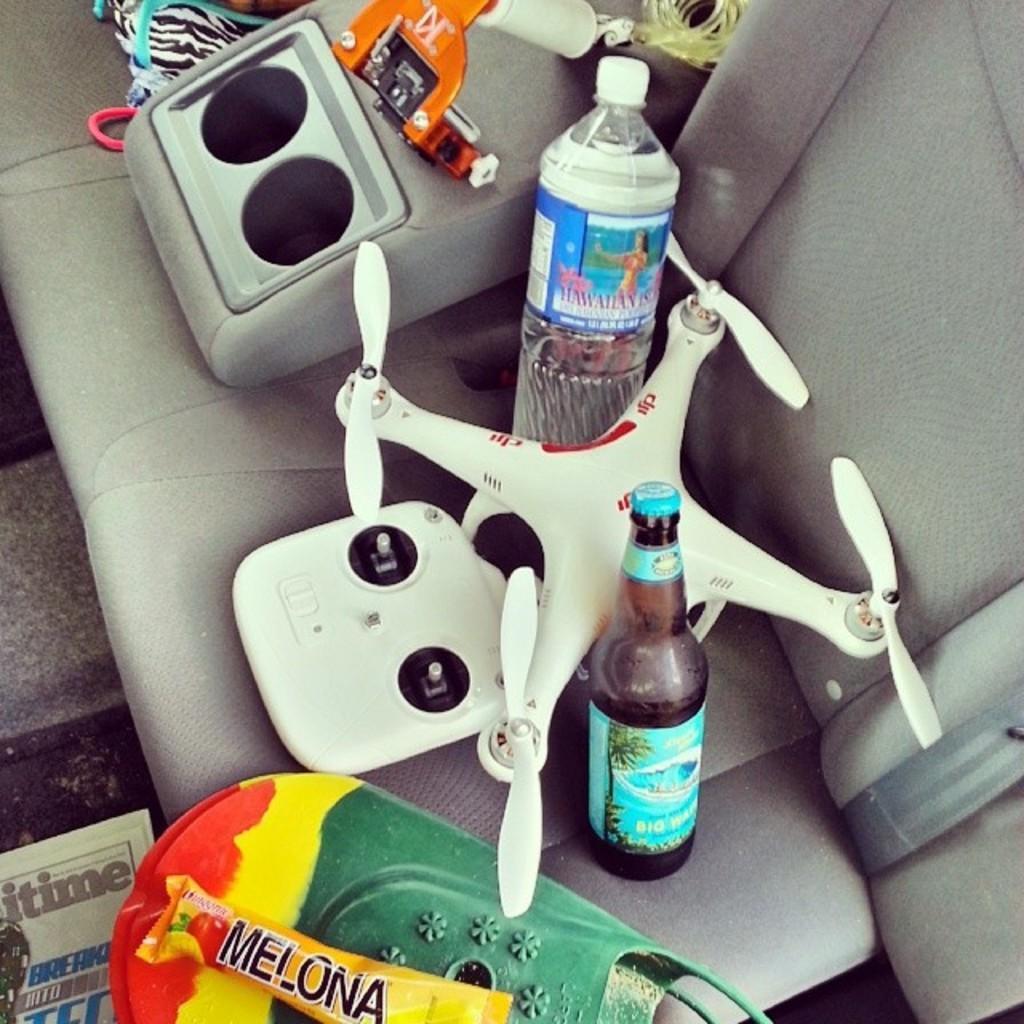Could you give a brief overview of what you see in this image? There is a seat which has some objects placed on it. 